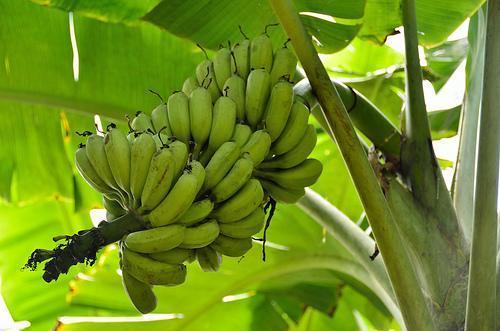How many rows are on the banana bunch?
Give a very brief answer. 4. How many bunches of bananas are pictured?
Give a very brief answer. 1. 